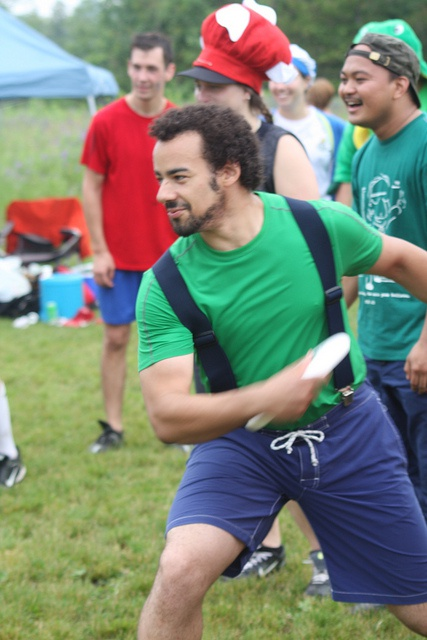Describe the objects in this image and their specific colors. I can see people in lightblue, navy, green, black, and tan tones, people in lightblue, teal, gray, and lightpink tones, people in lightblue, brown, tan, and lightpink tones, people in lightblue, lightgray, salmon, gray, and brown tones, and chair in lightblue, white, brown, and gray tones in this image. 